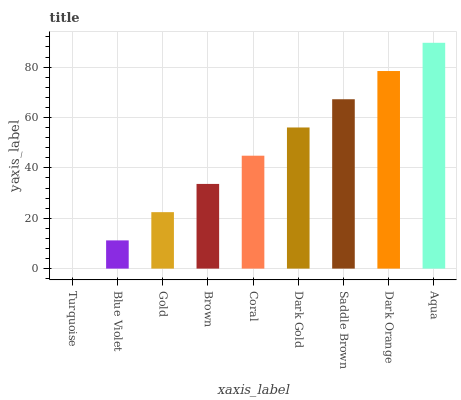Is Turquoise the minimum?
Answer yes or no. Yes. Is Aqua the maximum?
Answer yes or no. Yes. Is Blue Violet the minimum?
Answer yes or no. No. Is Blue Violet the maximum?
Answer yes or no. No. Is Blue Violet greater than Turquoise?
Answer yes or no. Yes. Is Turquoise less than Blue Violet?
Answer yes or no. Yes. Is Turquoise greater than Blue Violet?
Answer yes or no. No. Is Blue Violet less than Turquoise?
Answer yes or no. No. Is Coral the high median?
Answer yes or no. Yes. Is Coral the low median?
Answer yes or no. Yes. Is Dark Orange the high median?
Answer yes or no. No. Is Dark Orange the low median?
Answer yes or no. No. 